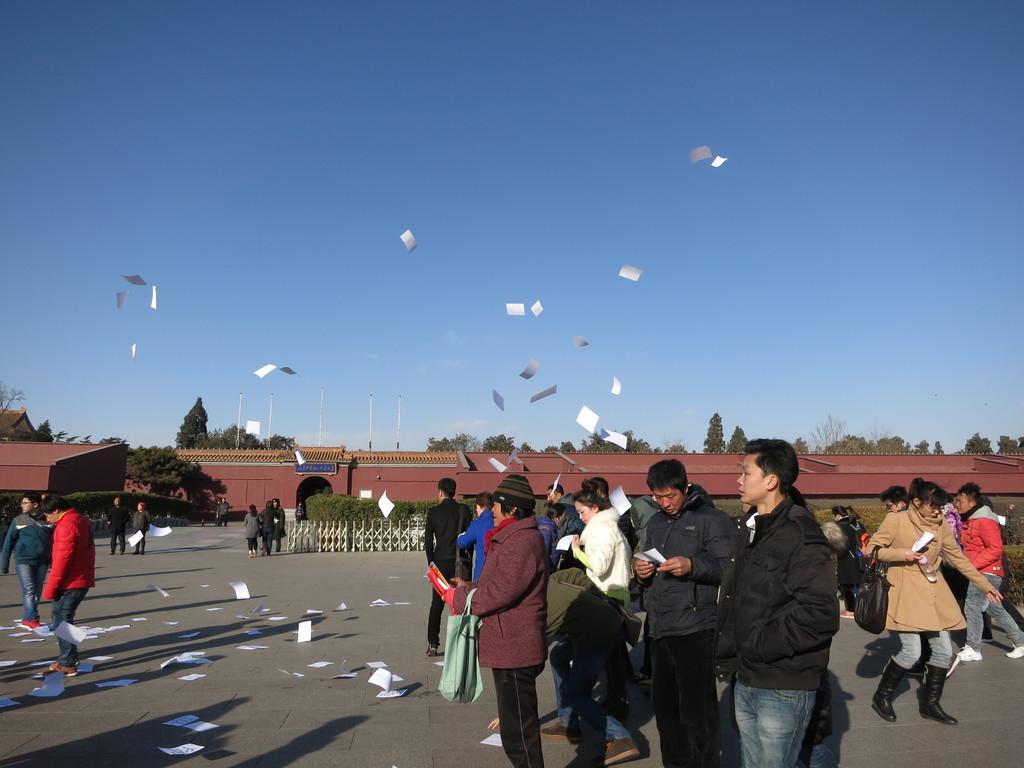Could you give a brief overview of what you see in this image? In this picture I can see few people standing and few are walking and I can see few papers in the air and few papers on the ground and I can see few of them holding papers in their hands and I can see trees, buildings and few poles and a blue sky. 